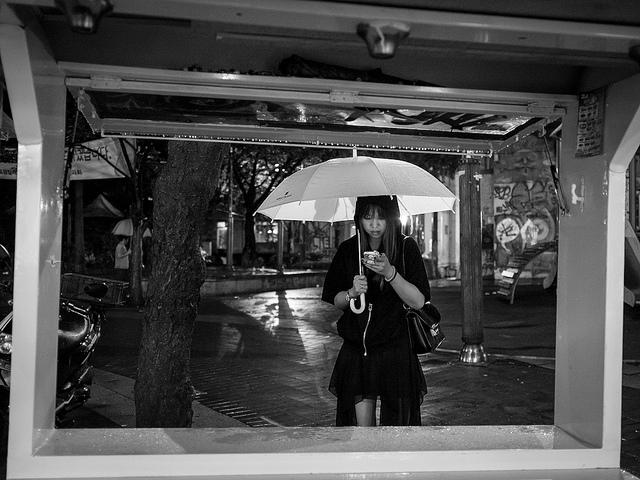Is the image in black and white?
Quick response, please. Yes. What is the brightest item in the image?
Quick response, please. Umbrella. How many items is the girl carrying?
Quick response, please. 3. 